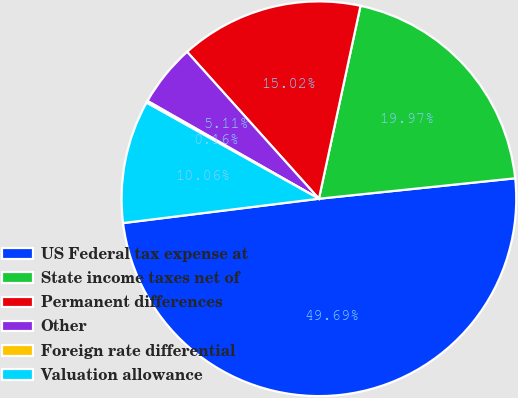Convert chart. <chart><loc_0><loc_0><loc_500><loc_500><pie_chart><fcel>US Federal tax expense at<fcel>State income taxes net of<fcel>Permanent differences<fcel>Other<fcel>Foreign rate differential<fcel>Valuation allowance<nl><fcel>49.69%<fcel>19.97%<fcel>15.02%<fcel>5.11%<fcel>0.16%<fcel>10.06%<nl></chart> 